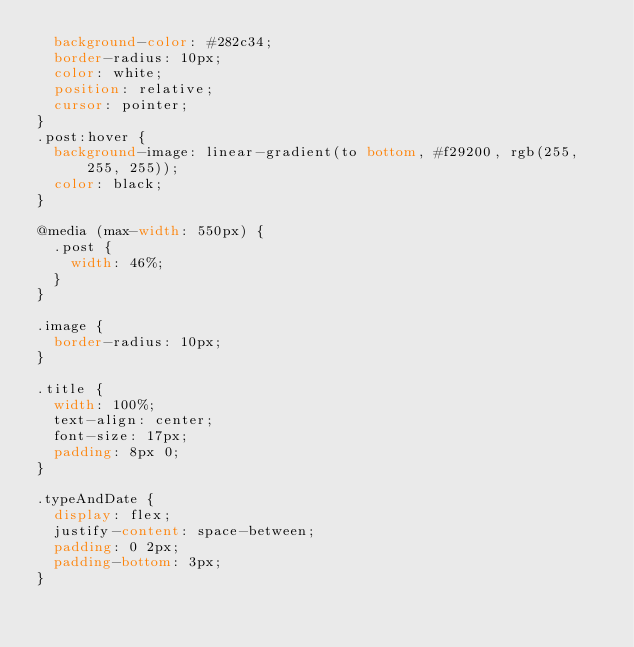<code> <loc_0><loc_0><loc_500><loc_500><_CSS_>  background-color: #282c34;
  border-radius: 10px;
  color: white;
  position: relative;
  cursor: pointer;
}
.post:hover {
  background-image: linear-gradient(to bottom, #f29200, rgb(255, 255, 255));
  color: black;
}

@media (max-width: 550px) {
  .post {
    width: 46%;
  }
}

.image {
  border-radius: 10px;
}

.title {
  width: 100%;
  text-align: center;
  font-size: 17px;
  padding: 8px 0;
}

.typeAndDate {
  display: flex;
  justify-content: space-between;
  padding: 0 2px;
  padding-bottom: 3px;
}
</code> 